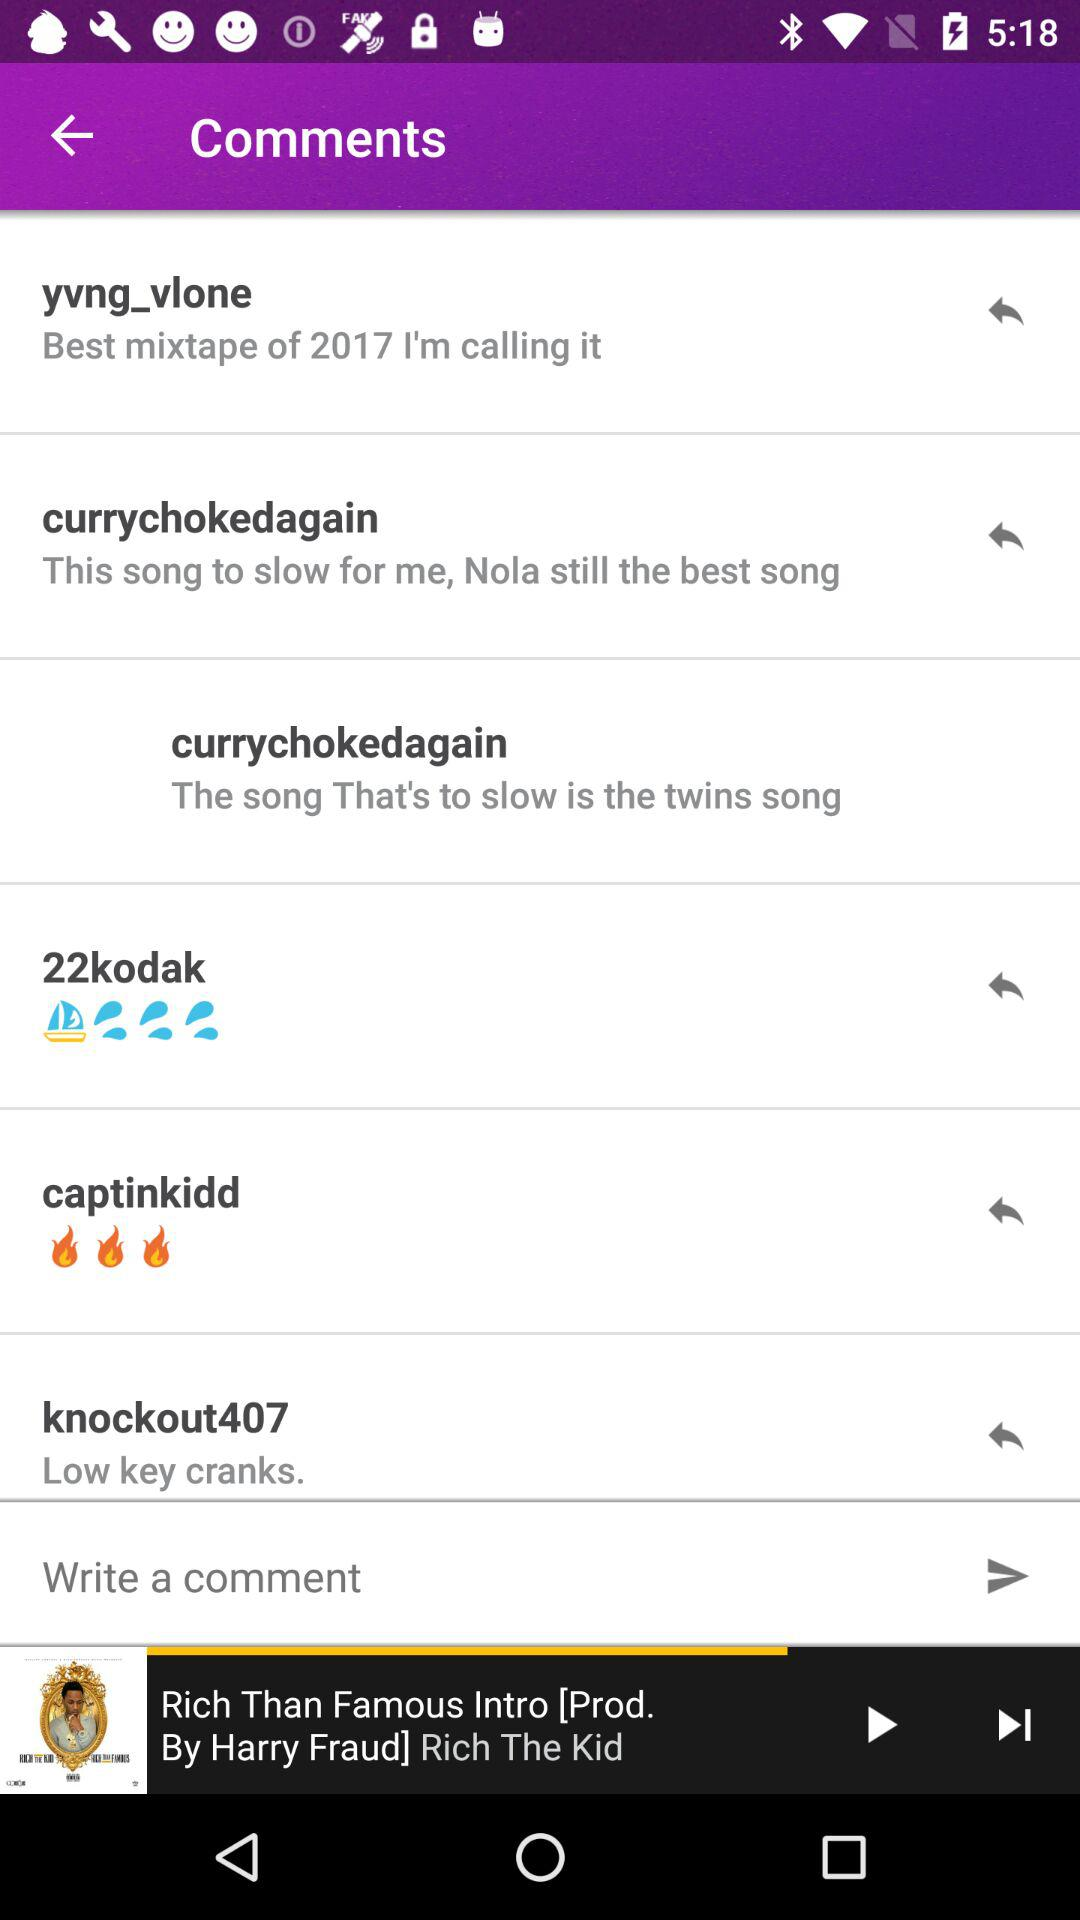Which song was last played? The last played song was "Rich Than Famous Intro". 